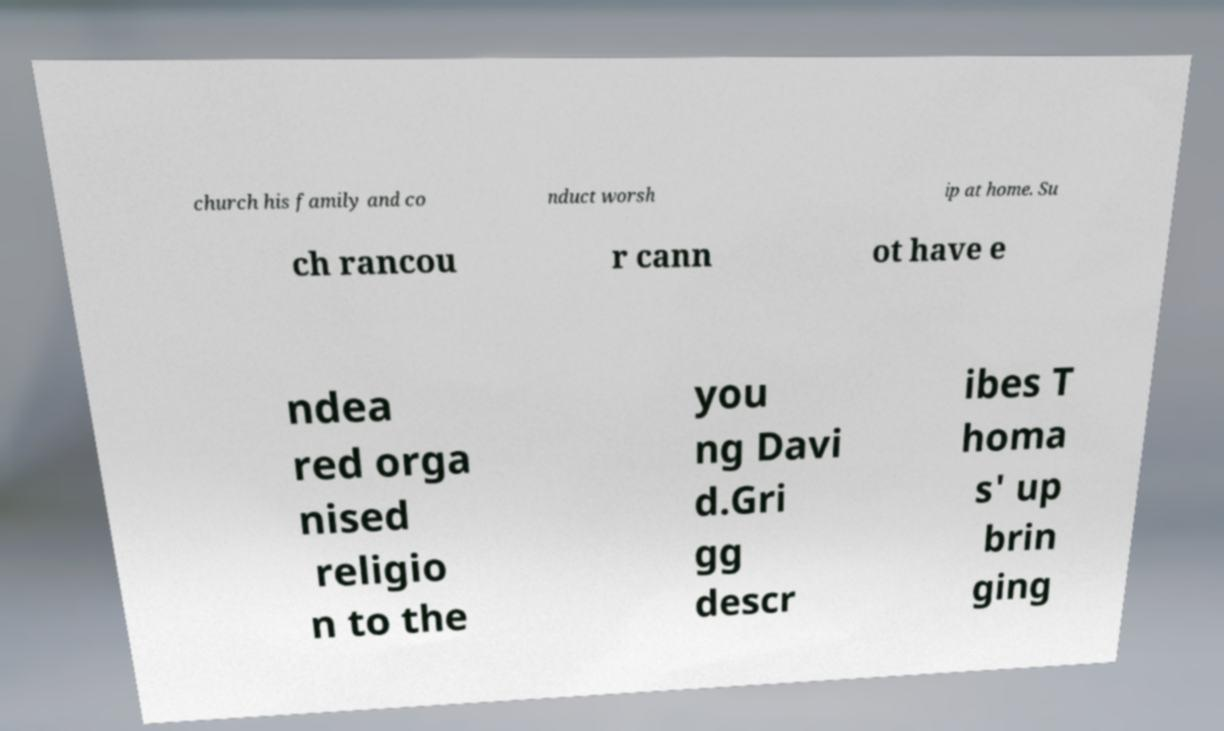Could you extract and type out the text from this image? church his family and co nduct worsh ip at home. Su ch rancou r cann ot have e ndea red orga nised religio n to the you ng Davi d.Gri gg descr ibes T homa s' up brin ging 